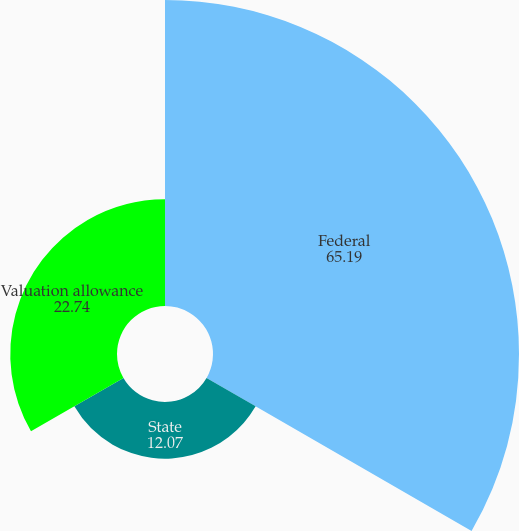<chart> <loc_0><loc_0><loc_500><loc_500><pie_chart><fcel>Federal<fcel>State<fcel>Valuation allowance<nl><fcel>65.19%<fcel>12.07%<fcel>22.74%<nl></chart> 